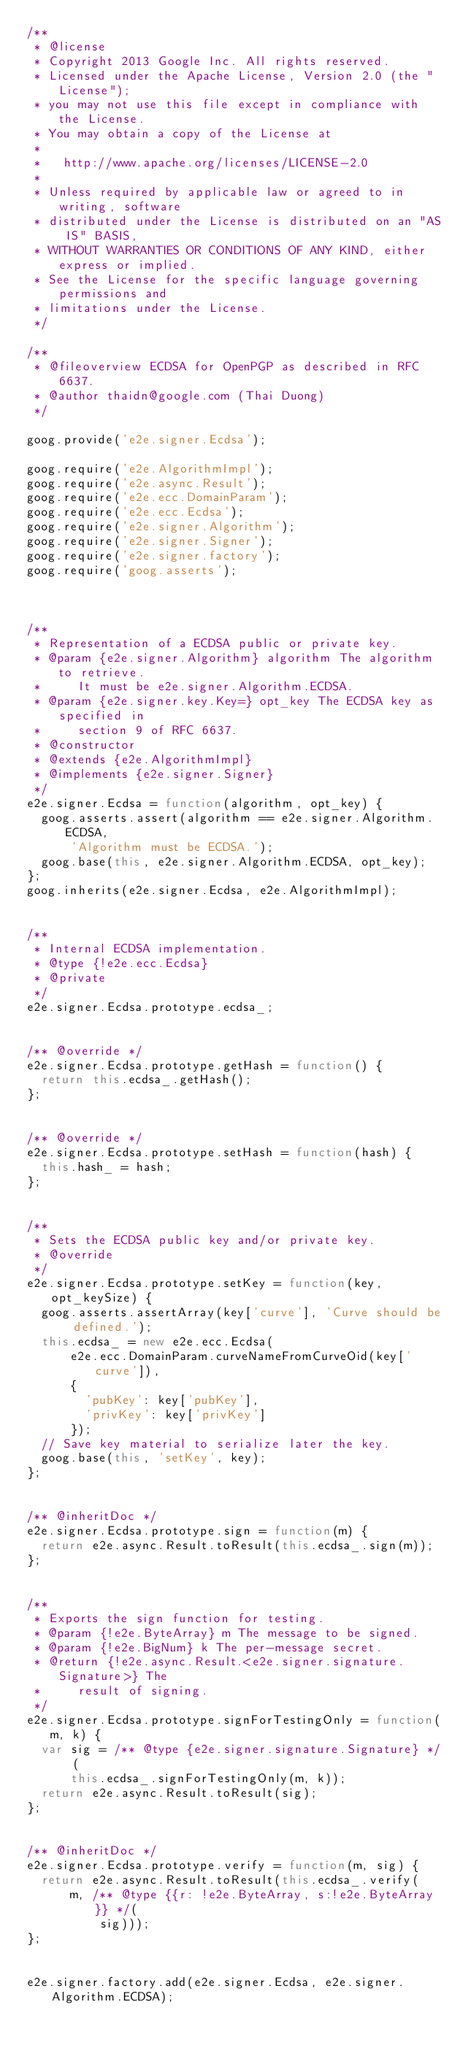<code> <loc_0><loc_0><loc_500><loc_500><_JavaScript_>/**
 * @license
 * Copyright 2013 Google Inc. All rights reserved.
 * Licensed under the Apache License, Version 2.0 (the "License");
 * you may not use this file except in compliance with the License.
 * You may obtain a copy of the License at
 *
 *   http://www.apache.org/licenses/LICENSE-2.0
 *
 * Unless required by applicable law or agreed to in writing, software
 * distributed under the License is distributed on an "AS IS" BASIS,
 * WITHOUT WARRANTIES OR CONDITIONS OF ANY KIND, either express or implied.
 * See the License for the specific language governing permissions and
 * limitations under the License.
 */

/**
 * @fileoverview ECDSA for OpenPGP as described in RFC 6637.
 * @author thaidn@google.com (Thai Duong)
 */

goog.provide('e2e.signer.Ecdsa');

goog.require('e2e.AlgorithmImpl');
goog.require('e2e.async.Result');
goog.require('e2e.ecc.DomainParam');
goog.require('e2e.ecc.Ecdsa');
goog.require('e2e.signer.Algorithm');
goog.require('e2e.signer.Signer');
goog.require('e2e.signer.factory');
goog.require('goog.asserts');



/**
 * Representation of a ECDSA public or private key.
 * @param {e2e.signer.Algorithm} algorithm The algorithm to retrieve.
 *     It must be e2e.signer.Algorithm.ECDSA.
 * @param {e2e.signer.key.Key=} opt_key The ECDSA key as specified in
 *     section 9 of RFC 6637.
 * @constructor
 * @extends {e2e.AlgorithmImpl}
 * @implements {e2e.signer.Signer}
 */
e2e.signer.Ecdsa = function(algorithm, opt_key) {
  goog.asserts.assert(algorithm == e2e.signer.Algorithm.ECDSA,
      'Algorithm must be ECDSA.');
  goog.base(this, e2e.signer.Algorithm.ECDSA, opt_key);
};
goog.inherits(e2e.signer.Ecdsa, e2e.AlgorithmImpl);


/**
 * Internal ECDSA implementation.
 * @type {!e2e.ecc.Ecdsa}
 * @private
 */
e2e.signer.Ecdsa.prototype.ecdsa_;


/** @override */
e2e.signer.Ecdsa.prototype.getHash = function() {
  return this.ecdsa_.getHash();
};


/** @override */
e2e.signer.Ecdsa.prototype.setHash = function(hash) {
  this.hash_ = hash;
};


/**
 * Sets the ECDSA public key and/or private key.
 * @override
 */
e2e.signer.Ecdsa.prototype.setKey = function(key, opt_keySize) {
  goog.asserts.assertArray(key['curve'], 'Curve should be defined.');
  this.ecdsa_ = new e2e.ecc.Ecdsa(
      e2e.ecc.DomainParam.curveNameFromCurveOid(key['curve']),
      {
        'pubKey': key['pubKey'],
        'privKey': key['privKey']
      });
  // Save key material to serialize later the key.
  goog.base(this, 'setKey', key);
};


/** @inheritDoc */
e2e.signer.Ecdsa.prototype.sign = function(m) {
  return e2e.async.Result.toResult(this.ecdsa_.sign(m));
};


/**
 * Exports the sign function for testing.
 * @param {!e2e.ByteArray} m The message to be signed.
 * @param {!e2e.BigNum} k The per-message secret.
 * @return {!e2e.async.Result.<e2e.signer.signature.Signature>} The
 *     result of signing.
 */
e2e.signer.Ecdsa.prototype.signForTestingOnly = function(m, k) {
  var sig = /** @type {e2e.signer.signature.Signature} */ (
      this.ecdsa_.signForTestingOnly(m, k));
  return e2e.async.Result.toResult(sig);
};


/** @inheritDoc */
e2e.signer.Ecdsa.prototype.verify = function(m, sig) {
  return e2e.async.Result.toResult(this.ecdsa_.verify(
      m, /** @type {{r: !e2e.ByteArray, s:!e2e.ByteArray}} */(
          sig)));
};


e2e.signer.factory.add(e2e.signer.Ecdsa, e2e.signer.Algorithm.ECDSA);
</code> 